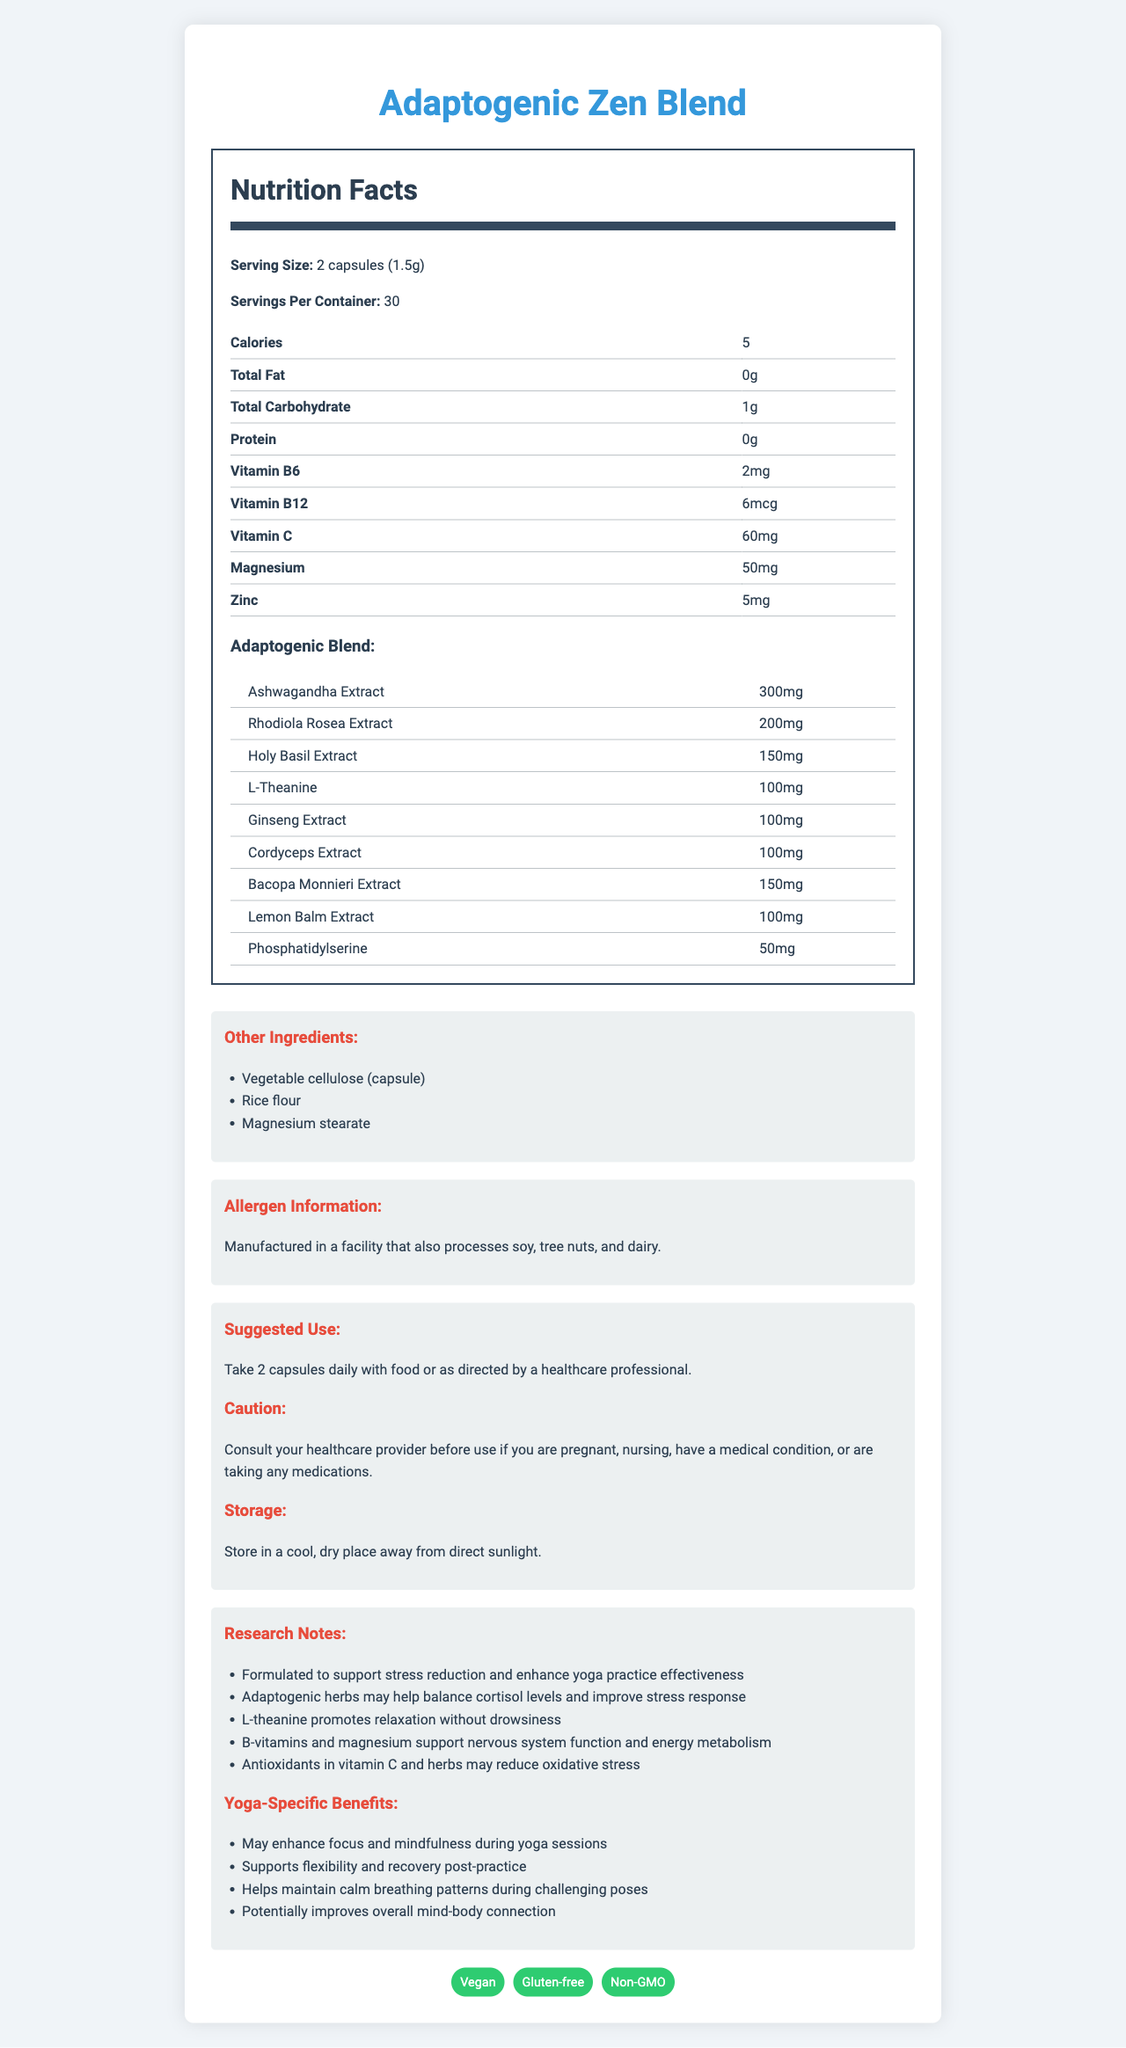what is the serving size of Adaptogenic Zen Blend? The serving size is specified as "2 capsules (1.5g)" in the Nutrition Facts section of the document.
Answer: 2 capsules (1.5g) how many servings are there per container? The document states that there are 30 servings per container.
Answer: 30 how much Vitamin C is in one serving? The document lists the amount of Vitamin C per serving as 60mg.
Answer: 60mg which adaptogenic herb is present in the highest amount in the blend? Ashwagandha Extract is listed at 300mg, which is the highest amount among the adaptogenic herbs present in the blend.
Answer: Ashwagandha Extract (300mg) are there any common allergens in the product? The allergen information section states that the product is manufactured in a facility that also processes soy, tree nuts, and dairy.
Answer: Yes which vitamin has the highest quantity per serving? A. Vitamin B6 B. Vitamin B12 C. Vitamin C Vitamin C has 60mg per serving, while Vitamin B6 has 2mg and Vitamin B12 has 6mcg.
Answer: C which of the following is not an adaptogenic herb in the blend? A. Rhodiola Rosea B. Ginseng C. Lemon Balm D. Echinacea Echinacea is not listed in the adaptogenic blend, whereas Rhodiola Rosea, Ginseng, and Lemon Balm are included.
Answer: D does the product contain animal-derived ingredients? The dietary considerations section states that the product is vegan, implying no animal-derived ingredients are used.
Answer: No what are the main purposes of Adaptogenic Zen Blend as described in the research notes? According to the research notes, the main purposes are to support stress reduction and enhance yoga practice effectiveness.
Answer: Support stress reduction and enhance yoga practice effectiveness what should you do before using this product if you are pregnant or nursing? The caution section advises consulting your healthcare provider before use if you are pregnant or nursing.
Answer: Consult your healthcare provider summarize the document. The document provides detailed information on the nutritional composition, serving size, ingredients, suggested use, and research-backed benefits of the Adaptogenic Zen Blend supplement, emphasizing its role in stress reduction and yoga enhancement.
Answer: Adaptogenic Zen Blend is a vegan, gluten-free, non-GMO supplement designed to support stress reduction and enhance yoga practice effectiveness. It contains a blend of adaptogenic herbs and key micronutrients such as Vitamins B6, B12, and C, Magnesium, and Zinc. The product is manufactured in a facility that also processes common allergens and is recommended to be taken as 2 capsules daily with food. how often should you take Adaptogenic Zen Blend? The suggested use section recommends taking 2 capsules daily.
Answer: Daily does the document provide information on how the adaptogenic herbs balance cortisol levels? While the research notes mention that adaptogenic herbs may help balance cortisol levels, the document does not provide detailed information on how this occurs.
Answer: No what is the main storage recommendation for the product? The storage section advises keeping the product in a cool, dry place away from direct sunlight.
Answer: Store in a cool, dry place away from direct sunlight 